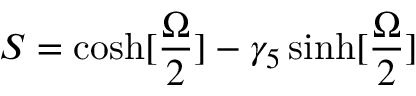Convert formula to latex. <formula><loc_0><loc_0><loc_500><loc_500>S = \cosh [ { \frac { \Omega } { 2 } } ] - \gamma _ { 5 } \sinh [ { \frac { \Omega } { 2 } } ]</formula> 